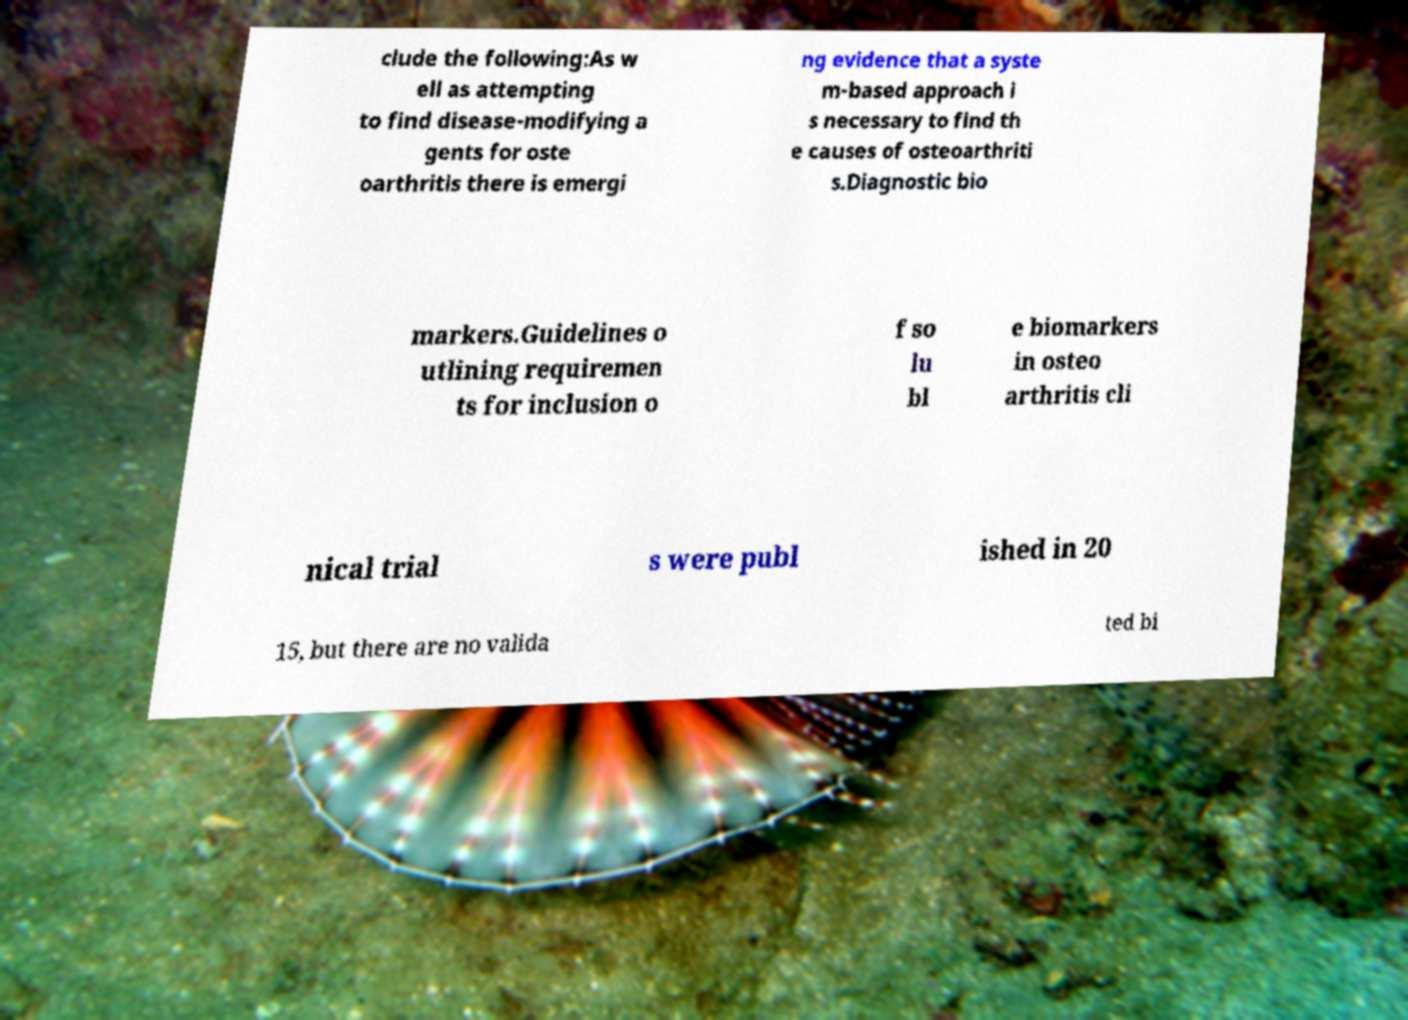I need the written content from this picture converted into text. Can you do that? clude the following:As w ell as attempting to find disease-modifying a gents for oste oarthritis there is emergi ng evidence that a syste m-based approach i s necessary to find th e causes of osteoarthriti s.Diagnostic bio markers.Guidelines o utlining requiremen ts for inclusion o f so lu bl e biomarkers in osteo arthritis cli nical trial s were publ ished in 20 15, but there are no valida ted bi 